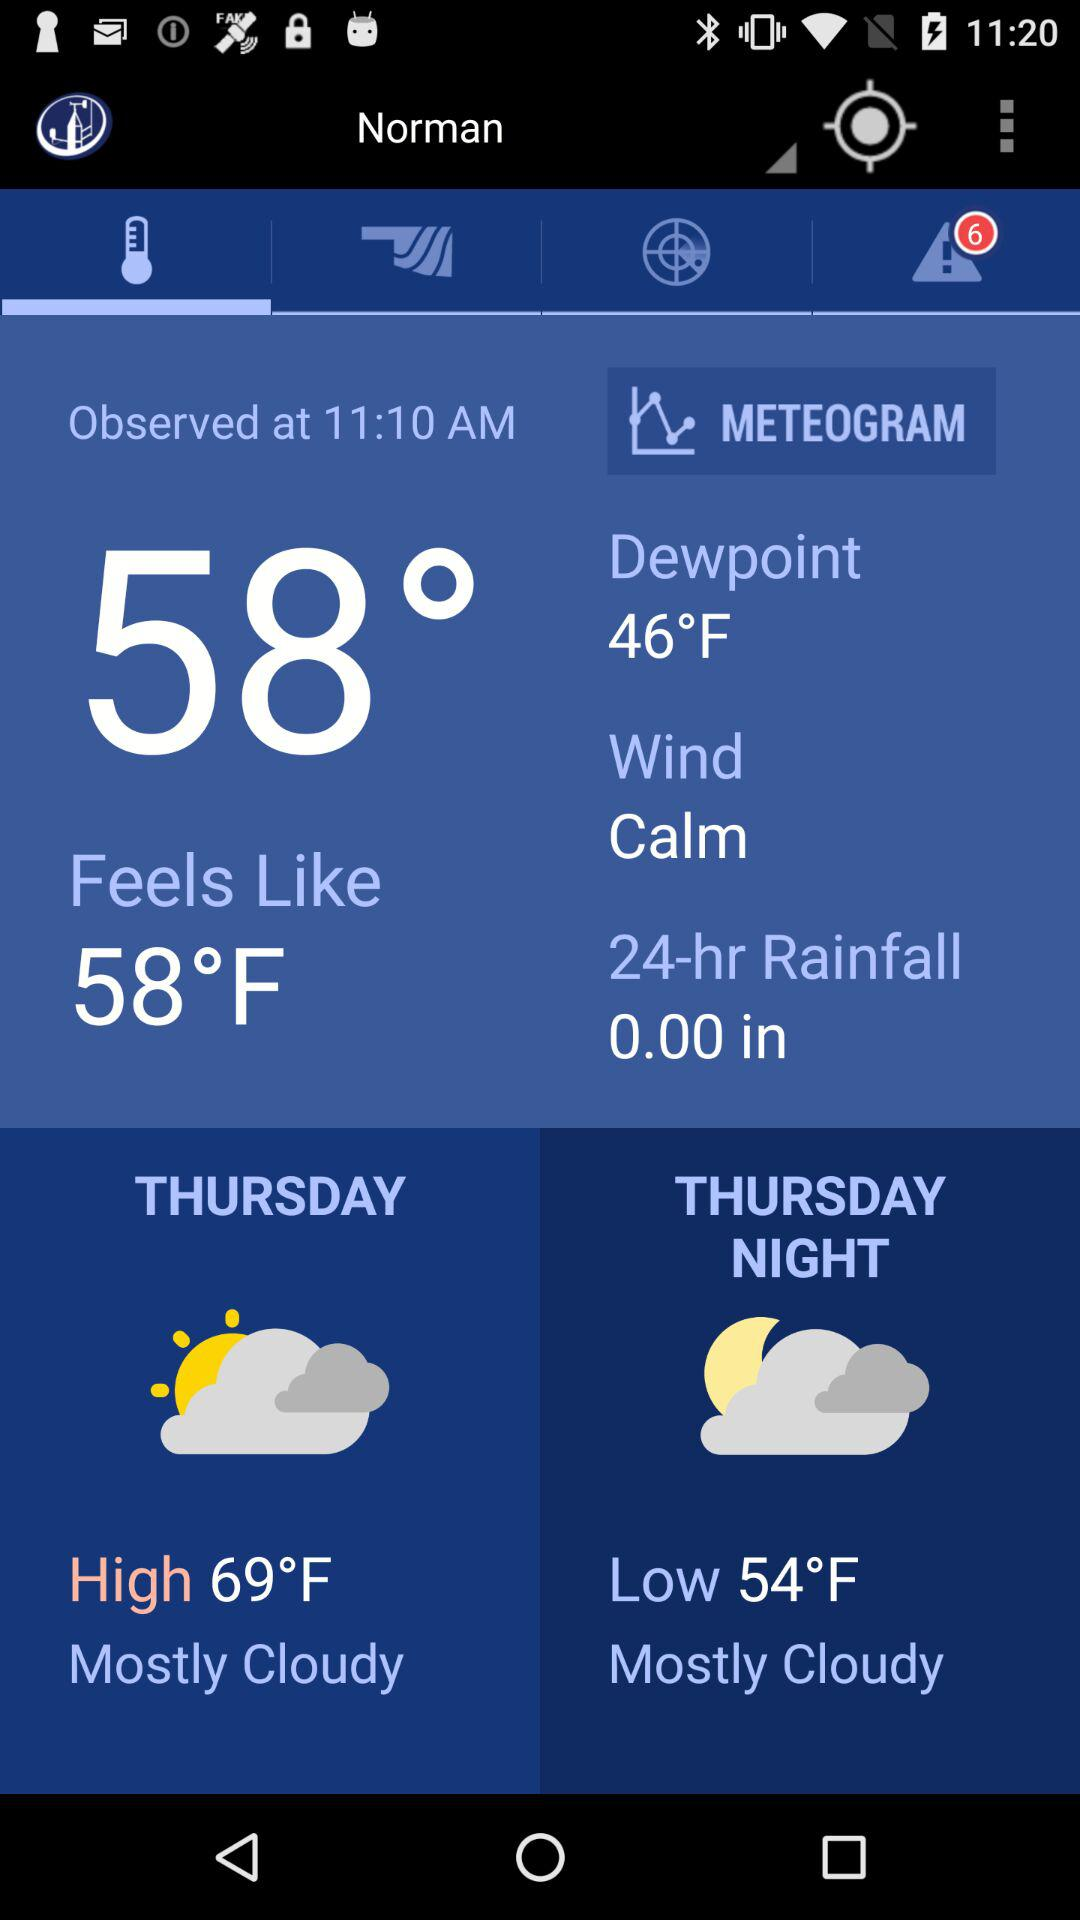What is the given time? The given time is 11:10 AM. 